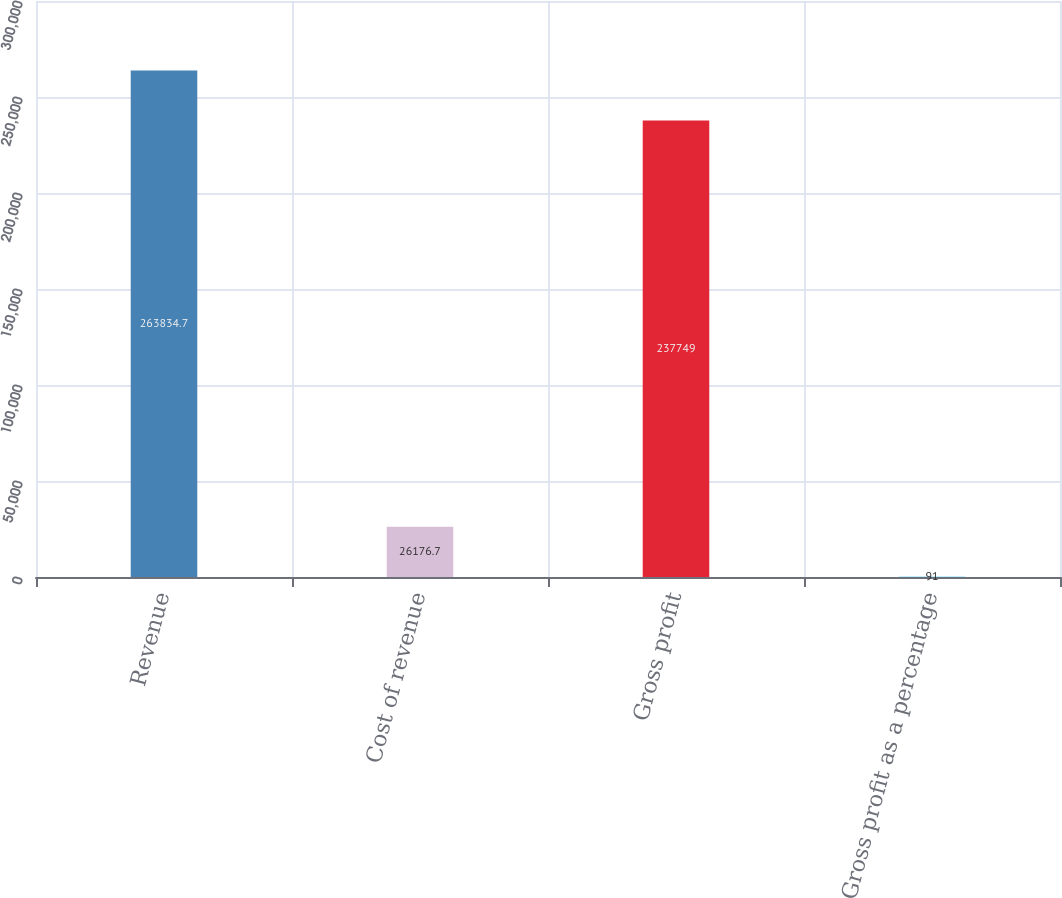Convert chart. <chart><loc_0><loc_0><loc_500><loc_500><bar_chart><fcel>Revenue<fcel>Cost of revenue<fcel>Gross profit<fcel>Gross profit as a percentage<nl><fcel>263835<fcel>26176.7<fcel>237749<fcel>91<nl></chart> 